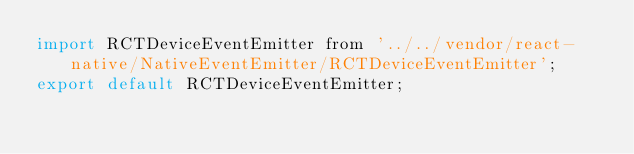<code> <loc_0><loc_0><loc_500><loc_500><_JavaScript_>import RCTDeviceEventEmitter from '../../vendor/react-native/NativeEventEmitter/RCTDeviceEventEmitter';
export default RCTDeviceEventEmitter;
</code> 